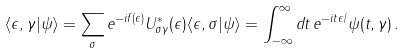Convert formula to latex. <formula><loc_0><loc_0><loc_500><loc_500>\langle \epsilon , \gamma | \psi \rangle = \sum _ { \sigma } e ^ { - i f ( \epsilon ) } U _ { \sigma \gamma } ^ { \ast } ( \epsilon ) \langle \epsilon , \sigma | \psi \rangle = \int _ { - \infty } ^ { \infty } d t \, e ^ { - i t \epsilon / } \psi ( t , \gamma ) \, .</formula> 